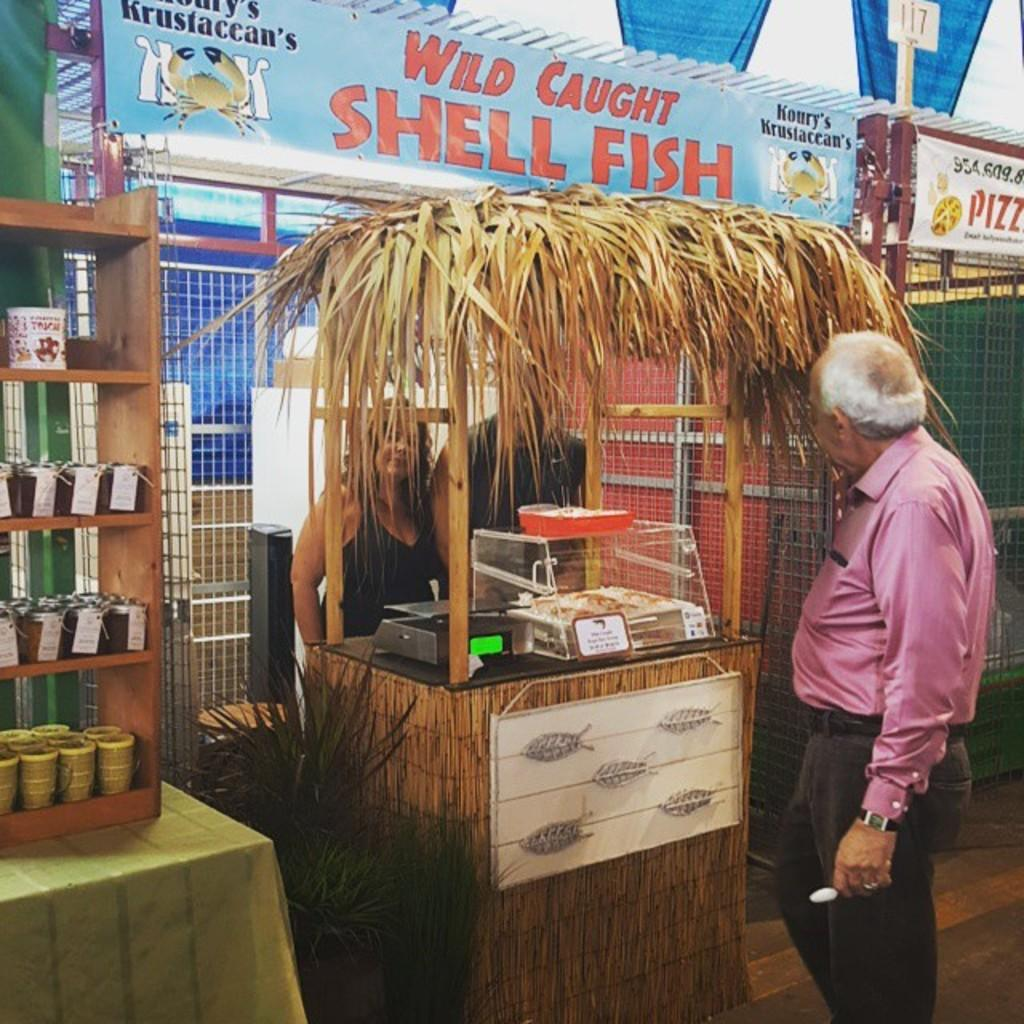<image>
Offer a succinct explanation of the picture presented. A man looking at a wild caught shell fish stand 